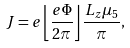Convert formula to latex. <formula><loc_0><loc_0><loc_500><loc_500>J = e \left \lfloor \frac { e \Phi } { 2 \pi } \right \rfloor \frac { L _ { z } \mu _ { 5 } } { \pi } ,</formula> 